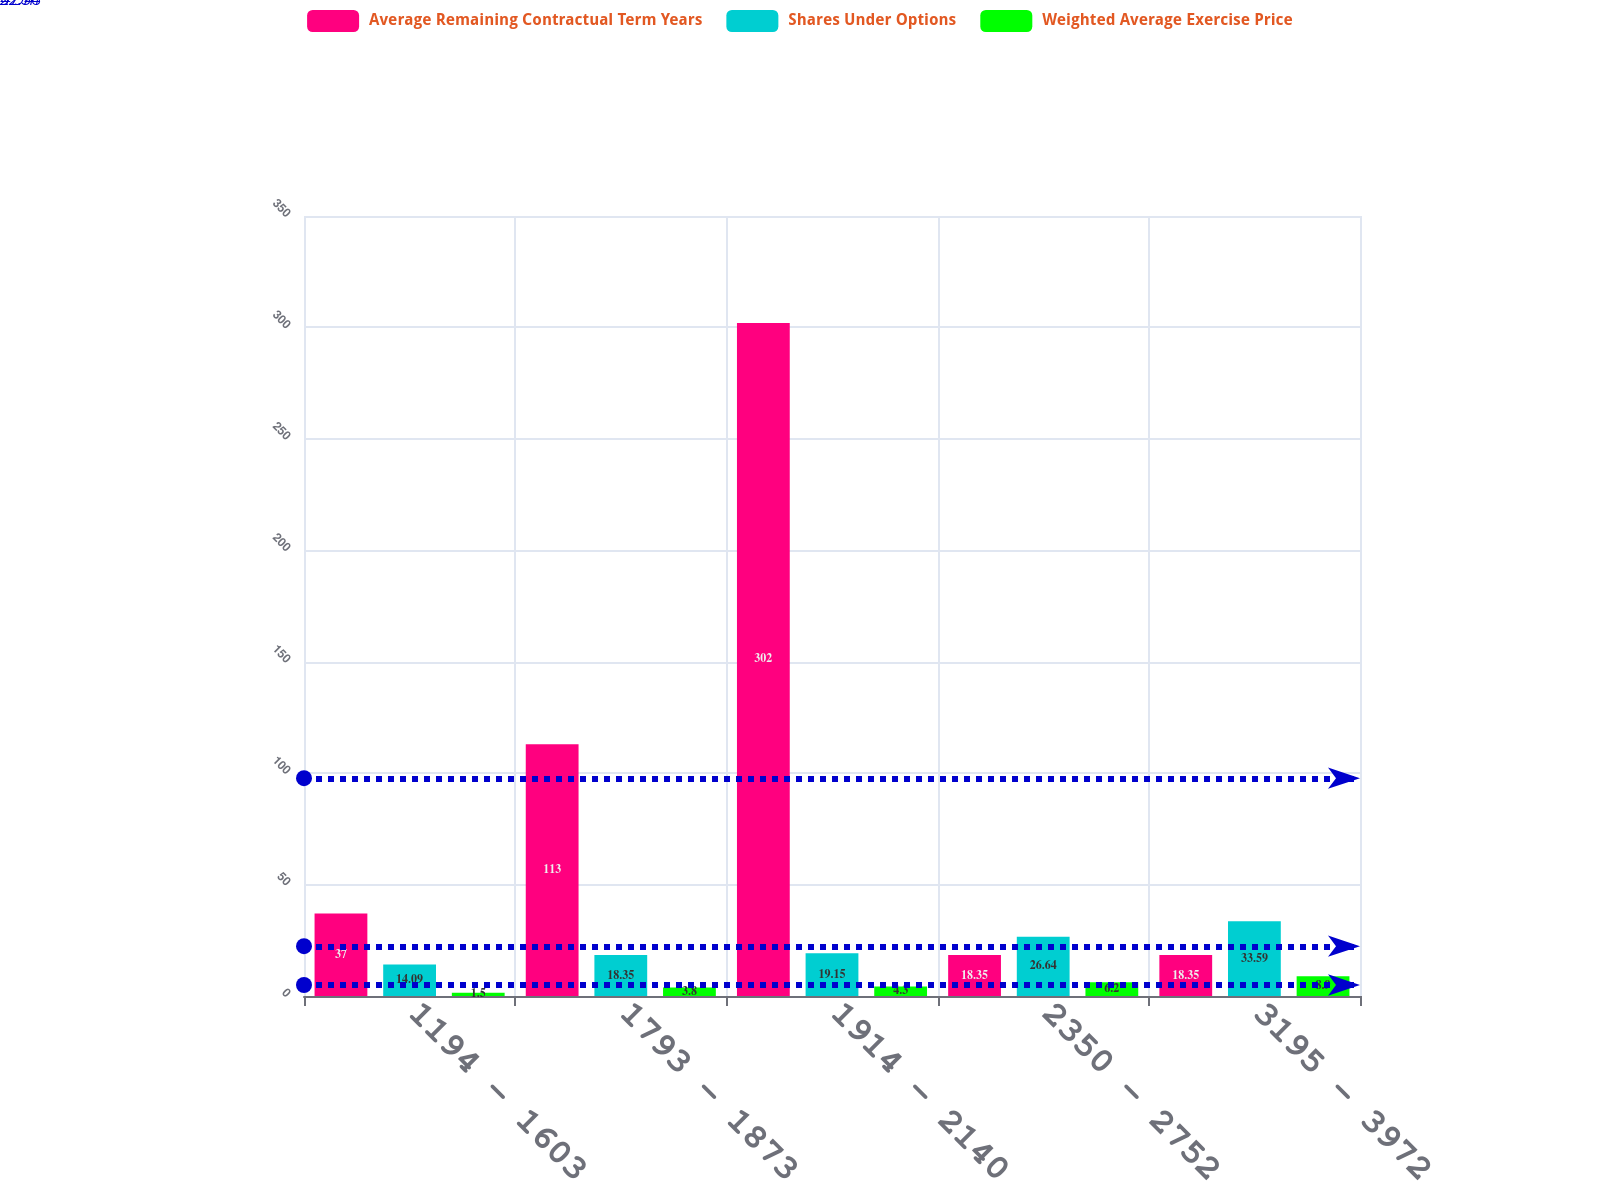<chart> <loc_0><loc_0><loc_500><loc_500><stacked_bar_chart><ecel><fcel>1194 - 1603<fcel>1793 - 1873<fcel>1914 - 2140<fcel>2350 - 2752<fcel>3195 - 3972<nl><fcel>Average Remaining Contractual Term Years<fcel>37<fcel>113<fcel>302<fcel>18.35<fcel>18.35<nl><fcel>Shares Under Options<fcel>14.09<fcel>18.35<fcel>19.15<fcel>26.64<fcel>33.59<nl><fcel>Weighted Average Exercise Price<fcel>1.5<fcel>3.8<fcel>4.3<fcel>6.2<fcel>8.9<nl></chart> 